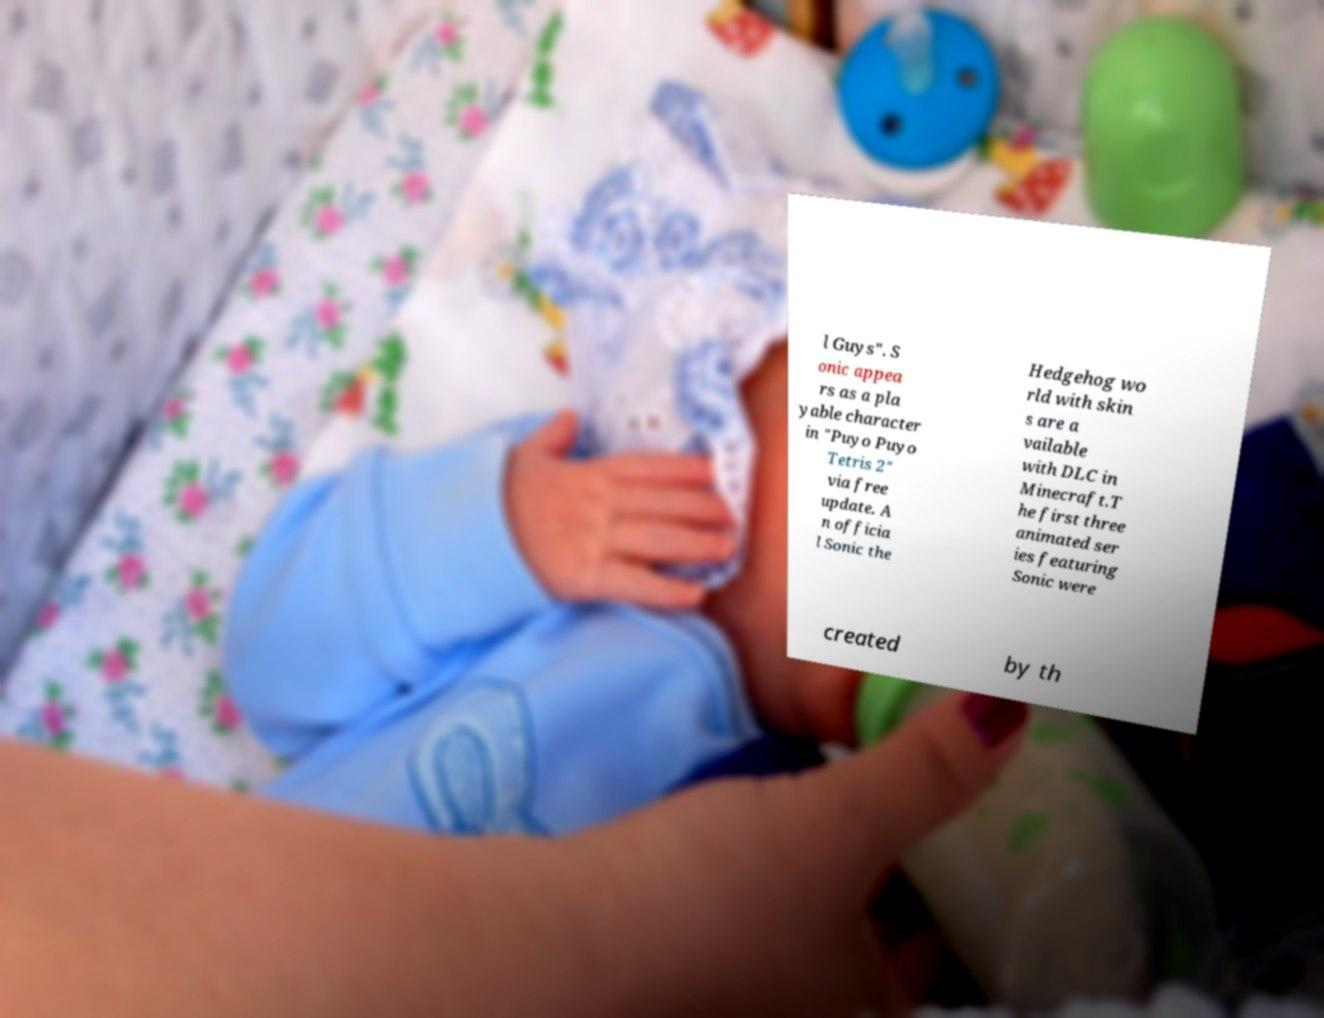Can you read and provide the text displayed in the image?This photo seems to have some interesting text. Can you extract and type it out for me? l Guys". S onic appea rs as a pla yable character in "Puyo Puyo Tetris 2" via free update. A n officia l Sonic the Hedgehog wo rld with skin s are a vailable with DLC in Minecraft.T he first three animated ser ies featuring Sonic were created by th 